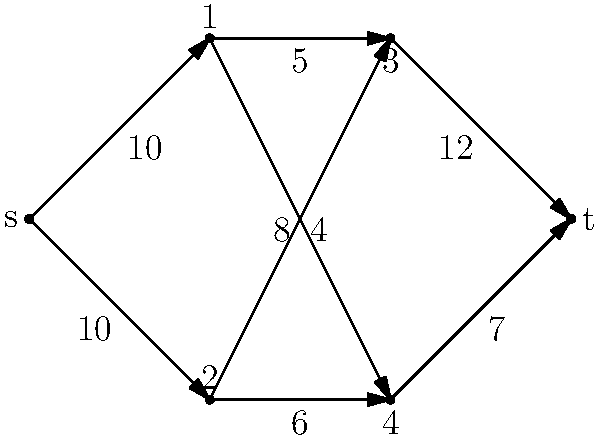Given the network flow diagram above, where 's' is the source and 't' is the sink, determine the maximum flow from 's' to 't'. How might this type of problem be relevant in optimizing resource allocation in an educational context? To solve this maximum flow problem, we'll use the Ford-Fulkerson algorithm:

1) Initialize all flows to 0.

2) Find augmenting paths from 's' to 't':

   Path 1: s → 1 → 3 → t (min capacity: 5)
   Flow becomes: 5
   
   Path 2: s → 1 → 4 → t (min capacity: 7)
   Flow becomes: 5 + 7 = 12
   
   Path 3: s → 2 → 3 → t (min capacity: 4)
   Flow becomes: 12 + 4 = 16
   
   Path 4: s → 2 → 4 → t (min capacity: 1)
   Flow becomes: 16 + 1 = 17

3) No more augmenting paths exist, so the maximum flow is 17.

In an educational context, this type of problem could be relevant for:

1) Optimizing student placement in courses or programs based on capacity constraints.
2) Allocating resources (e.g., classrooms, teachers) efficiently across different departments or campuses.
3) Managing the flow of information or materials in distance learning scenarios.
4) Planning optimal routes for student transportation systems.

Understanding and applying such network flow concepts can significantly enhance resource utilization and decision-making processes in educational institutions.
Answer: 17 units 